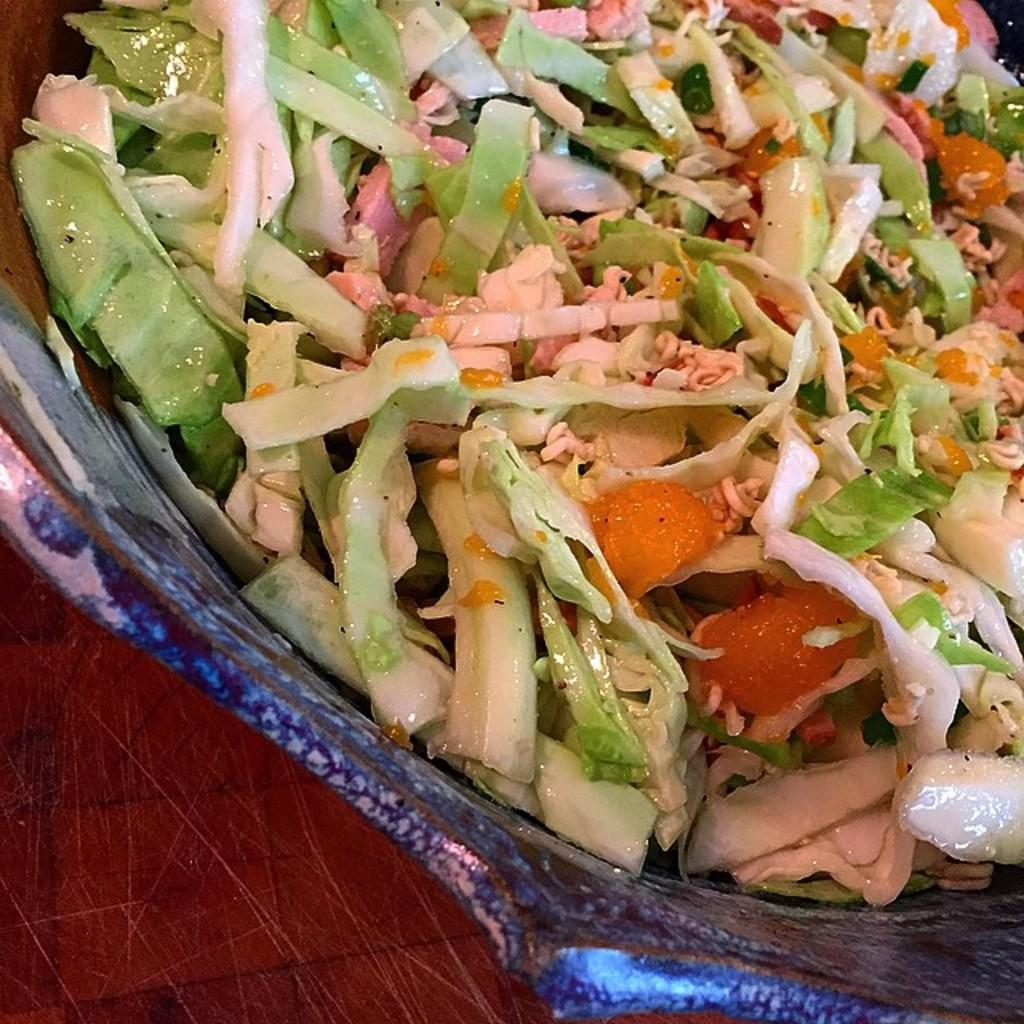What is placed in a bowl in the image? There is an eatable item placed in a bowl in the image. How many bells can be heard ringing in the image? There are no bells present in the image, so it is not possible to hear any ringing. 